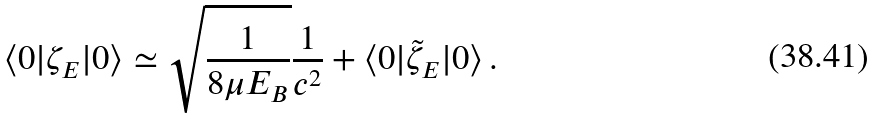<formula> <loc_0><loc_0><loc_500><loc_500>\langle 0 | \zeta _ { E } | 0 \rangle \simeq \sqrt { \frac { 1 } { 8 \mu E _ { B } } } \frac { 1 } { c ^ { 2 } } + \langle 0 | \tilde { \zeta } _ { E } | 0 \rangle \, .</formula> 